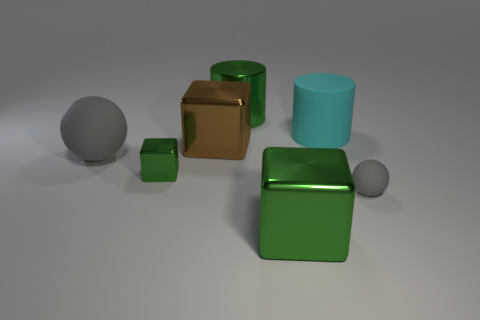What size is the brown block?
Ensure brevity in your answer.  Large. There is a gray sphere on the left side of the cyan cylinder to the right of the block to the right of the brown metallic thing; what is it made of?
Offer a terse response. Rubber. What is the color of the big ball that is made of the same material as the small sphere?
Keep it short and to the point. Gray. How many tiny gray rubber balls are in front of the green object right of the green cylinder left of the tiny gray thing?
Keep it short and to the point. 0. There is a large cylinder that is the same color as the small cube; what is its material?
Make the answer very short. Metal. Are there any other things that have the same shape as the small metallic object?
Offer a very short reply. Yes. What number of objects are either large gray rubber things in front of the cyan rubber cylinder or large gray balls?
Make the answer very short. 1. Does the metal block right of the big green cylinder have the same color as the tiny block?
Your answer should be compact. Yes. What shape is the big green metal object that is behind the green metal object in front of the small gray sphere?
Keep it short and to the point. Cylinder. Are there fewer big shiny blocks behind the small green object than large rubber cylinders that are behind the large green shiny cylinder?
Your answer should be very brief. No. 